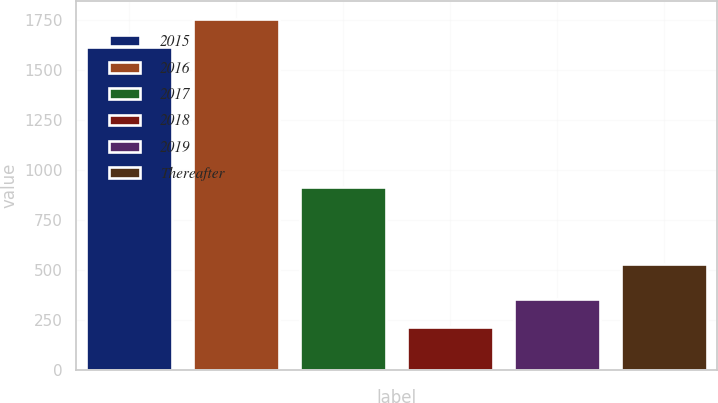Convert chart to OTSL. <chart><loc_0><loc_0><loc_500><loc_500><bar_chart><fcel>2015<fcel>2016<fcel>2017<fcel>2018<fcel>2019<fcel>Thereafter<nl><fcel>1613<fcel>1753<fcel>913<fcel>213<fcel>353<fcel>531<nl></chart> 